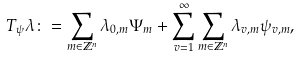Convert formula to latex. <formula><loc_0><loc_0><loc_500><loc_500>T _ { \psi } \lambda \colon = \sum _ { m \in \mathbb { Z } ^ { n } } \lambda _ { 0 , m } \Psi _ { m } + \sum _ { v = 1 } ^ { \infty } \sum _ { m \in \mathbb { Z } ^ { n } } \lambda _ { v , m } \psi _ { v , m } ,</formula> 